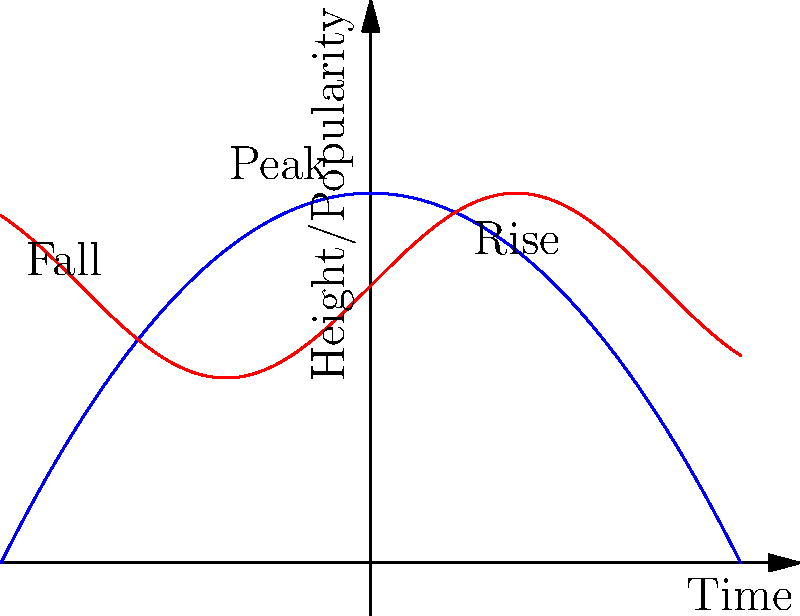The blue curve represents the trajectory of a projectile, while the red curve represents the rise and fall of a political movement over time. How does the symmetry of the projectile's path compare to the cyclical nature of the political movement, and what implications might this have for understanding political dynamics? To answer this question, let's analyze both curves step-by-step:

1. Projectile trajectory (blue curve):
   - Follows a parabolic path described by the equation $y = -ax^2 + b$
   - Perfectly symmetrical around its vertex (peak)
   - Has a clear beginning, peak, and end

2. Political movement (red curve):
   - Follows a sinusoidal pattern described by $y = A \sin(\omega x) + B$
   - Cyclical and repeating
   - No definite beginning or end

3. Comparison:
   - Symmetry: The projectile's path is symmetrical, while the political movement is periodic but not necessarily symmetrical within one cycle.
   - Predictability: The projectile's path is more predictable, given initial conditions. The political movement has more variability.
   - Duration: The projectile has a finite trajectory, while the political movement can potentially continue indefinitely.

4. Implications for political dynamics:
   - Political movements may not have a clear "end" like a projectile does
   - The rise and fall of political movements can be cyclical, potentially resurging after a decline
   - External factors (analogous to wind resistance for a projectile) can cause deviations from the expected pattern in political movements
   - Understanding these differences can help in analyzing and predicting political trends over time

5. Physics connection:
   - The projectile motion is governed by Newton's laws of motion and gravity
   - Political movements are influenced by social, economic, and cultural factors, which are less quantifiable but may follow certain patterns

By comparing these two phenomena, we can gain insights into the nature of political movements and their potential for recurring influence over time, unlike the finite path of a projectile.
Answer: The projectile's symmetrical path contrasts with the cyclical, potentially infinite nature of political movements, implying that political dynamics may have recurring patterns and longer-term influences than singular events. 